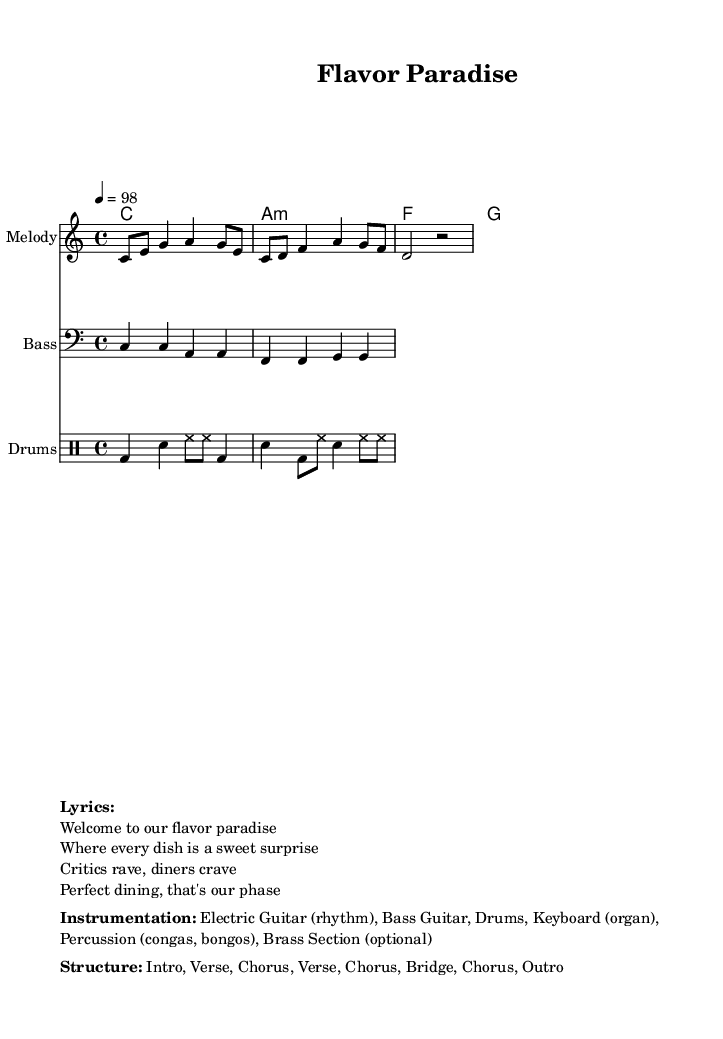What is the key signature of this music? The key signature is C major, which has no sharps or flats.
Answer: C major What is the time signature of the piece? The time signature is indicated by the `\time` directive which shows four beats per measure.
Answer: 4/4 What is the tempo of the song? The tempo is marked with `\tempo` showing that there are 98 beats per minute.
Answer: 98 How many sections are in the song structure? The structure lists seven distinct sections: Intro, Verse, Chorus, Verse, Chorus, Bridge, Chorus, Outro.
Answer: 7 Which instruments are included in the instrumentation? The instrumentation includes electric guitar, bass guitar, drums, keyboard, percussion, and an optional brass section.
Answer: Electric Guitar, Bass Guitar, Drums, Keyboard, Percussion, Brass Section What type of rhythm is predominantly used in the drums? The drumming style follows a typical reggae pattern with kick, snare, and hi-hat transitions.
Answer: Reggae pattern What is the central theme of the lyrics? The lyrics focus on creating a delightful and praised dining experience for critics and diners alike.
Answer: Flavor Paradise 